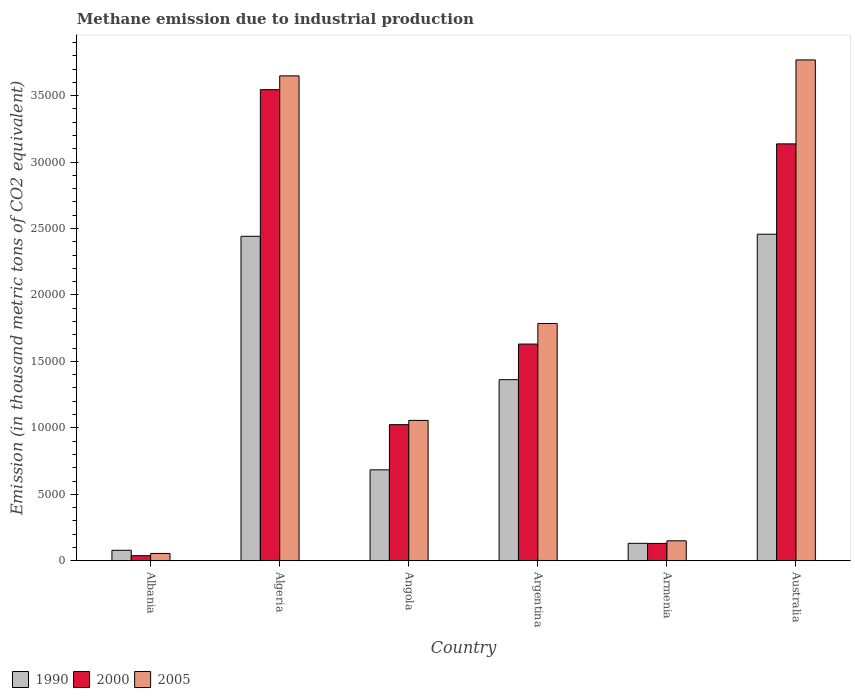How many different coloured bars are there?
Provide a short and direct response. 3. How many groups of bars are there?
Your answer should be compact. 6. What is the label of the 2nd group of bars from the left?
Your answer should be compact. Algeria. In how many cases, is the number of bars for a given country not equal to the number of legend labels?
Provide a short and direct response. 0. What is the amount of methane emitted in 2005 in Algeria?
Offer a very short reply. 3.65e+04. Across all countries, what is the maximum amount of methane emitted in 1990?
Give a very brief answer. 2.46e+04. Across all countries, what is the minimum amount of methane emitted in 2005?
Your answer should be very brief. 550.9. In which country was the amount of methane emitted in 2005 maximum?
Provide a short and direct response. Australia. In which country was the amount of methane emitted in 2000 minimum?
Make the answer very short. Albania. What is the total amount of methane emitted in 2000 in the graph?
Your answer should be compact. 9.51e+04. What is the difference between the amount of methane emitted in 2000 in Algeria and that in Australia?
Offer a very short reply. 4079.4. What is the difference between the amount of methane emitted in 1990 in Armenia and the amount of methane emitted in 2005 in Angola?
Provide a succinct answer. -9249.2. What is the average amount of methane emitted in 2000 per country?
Your answer should be compact. 1.58e+04. What is the difference between the amount of methane emitted of/in 2005 and amount of methane emitted of/in 2000 in Australia?
Your answer should be compact. 6316.4. In how many countries, is the amount of methane emitted in 1990 greater than 14000 thousand metric tons?
Your answer should be compact. 2. What is the ratio of the amount of methane emitted in 2005 in Angola to that in Argentina?
Your response must be concise. 0.59. Is the amount of methane emitted in 2000 in Angola less than that in Australia?
Provide a succinct answer. Yes. Is the difference between the amount of methane emitted in 2005 in Argentina and Australia greater than the difference between the amount of methane emitted in 2000 in Argentina and Australia?
Offer a terse response. No. What is the difference between the highest and the second highest amount of methane emitted in 2005?
Offer a terse response. -1199.5. What is the difference between the highest and the lowest amount of methane emitted in 2005?
Your answer should be compact. 3.71e+04. In how many countries, is the amount of methane emitted in 1990 greater than the average amount of methane emitted in 1990 taken over all countries?
Make the answer very short. 3. Is the sum of the amount of methane emitted in 1990 in Albania and Armenia greater than the maximum amount of methane emitted in 2005 across all countries?
Provide a short and direct response. No. Is it the case that in every country, the sum of the amount of methane emitted in 2005 and amount of methane emitted in 2000 is greater than the amount of methane emitted in 1990?
Ensure brevity in your answer.  Yes. How many bars are there?
Offer a terse response. 18. What is the difference between two consecutive major ticks on the Y-axis?
Your response must be concise. 5000. Are the values on the major ticks of Y-axis written in scientific E-notation?
Give a very brief answer. No. Does the graph contain any zero values?
Make the answer very short. No. Where does the legend appear in the graph?
Provide a short and direct response. Bottom left. What is the title of the graph?
Your answer should be compact. Methane emission due to industrial production. Does "1976" appear as one of the legend labels in the graph?
Your response must be concise. No. What is the label or title of the X-axis?
Ensure brevity in your answer.  Country. What is the label or title of the Y-axis?
Give a very brief answer. Emission (in thousand metric tons of CO2 equivalent). What is the Emission (in thousand metric tons of CO2 equivalent) of 1990 in Albania?
Give a very brief answer. 789.5. What is the Emission (in thousand metric tons of CO2 equivalent) of 2000 in Albania?
Offer a very short reply. 383.4. What is the Emission (in thousand metric tons of CO2 equivalent) of 2005 in Albania?
Give a very brief answer. 550.9. What is the Emission (in thousand metric tons of CO2 equivalent) in 1990 in Algeria?
Ensure brevity in your answer.  2.44e+04. What is the Emission (in thousand metric tons of CO2 equivalent) of 2000 in Algeria?
Your answer should be very brief. 3.54e+04. What is the Emission (in thousand metric tons of CO2 equivalent) in 2005 in Algeria?
Your answer should be compact. 3.65e+04. What is the Emission (in thousand metric tons of CO2 equivalent) of 1990 in Angola?
Your answer should be very brief. 6841.7. What is the Emission (in thousand metric tons of CO2 equivalent) of 2000 in Angola?
Your answer should be compact. 1.02e+04. What is the Emission (in thousand metric tons of CO2 equivalent) in 2005 in Angola?
Provide a short and direct response. 1.06e+04. What is the Emission (in thousand metric tons of CO2 equivalent) of 1990 in Argentina?
Keep it short and to the point. 1.36e+04. What is the Emission (in thousand metric tons of CO2 equivalent) of 2000 in Argentina?
Your answer should be compact. 1.63e+04. What is the Emission (in thousand metric tons of CO2 equivalent) of 2005 in Argentina?
Offer a very short reply. 1.79e+04. What is the Emission (in thousand metric tons of CO2 equivalent) of 1990 in Armenia?
Provide a short and direct response. 1313.2. What is the Emission (in thousand metric tons of CO2 equivalent) in 2000 in Armenia?
Offer a very short reply. 1306.1. What is the Emission (in thousand metric tons of CO2 equivalent) of 2005 in Armenia?
Offer a very short reply. 1502.5. What is the Emission (in thousand metric tons of CO2 equivalent) of 1990 in Australia?
Keep it short and to the point. 2.46e+04. What is the Emission (in thousand metric tons of CO2 equivalent) in 2000 in Australia?
Give a very brief answer. 3.14e+04. What is the Emission (in thousand metric tons of CO2 equivalent) in 2005 in Australia?
Ensure brevity in your answer.  3.77e+04. Across all countries, what is the maximum Emission (in thousand metric tons of CO2 equivalent) of 1990?
Give a very brief answer. 2.46e+04. Across all countries, what is the maximum Emission (in thousand metric tons of CO2 equivalent) of 2000?
Make the answer very short. 3.54e+04. Across all countries, what is the maximum Emission (in thousand metric tons of CO2 equivalent) of 2005?
Make the answer very short. 3.77e+04. Across all countries, what is the minimum Emission (in thousand metric tons of CO2 equivalent) of 1990?
Your answer should be very brief. 789.5. Across all countries, what is the minimum Emission (in thousand metric tons of CO2 equivalent) in 2000?
Your response must be concise. 383.4. Across all countries, what is the minimum Emission (in thousand metric tons of CO2 equivalent) of 2005?
Make the answer very short. 550.9. What is the total Emission (in thousand metric tons of CO2 equivalent) of 1990 in the graph?
Your answer should be compact. 7.16e+04. What is the total Emission (in thousand metric tons of CO2 equivalent) of 2000 in the graph?
Provide a succinct answer. 9.51e+04. What is the total Emission (in thousand metric tons of CO2 equivalent) of 2005 in the graph?
Offer a very short reply. 1.05e+05. What is the difference between the Emission (in thousand metric tons of CO2 equivalent) of 1990 in Albania and that in Algeria?
Your answer should be compact. -2.36e+04. What is the difference between the Emission (in thousand metric tons of CO2 equivalent) of 2000 in Albania and that in Algeria?
Offer a terse response. -3.51e+04. What is the difference between the Emission (in thousand metric tons of CO2 equivalent) of 2005 in Albania and that in Algeria?
Your answer should be very brief. -3.59e+04. What is the difference between the Emission (in thousand metric tons of CO2 equivalent) in 1990 in Albania and that in Angola?
Offer a terse response. -6052.2. What is the difference between the Emission (in thousand metric tons of CO2 equivalent) in 2000 in Albania and that in Angola?
Offer a very short reply. -9857.4. What is the difference between the Emission (in thousand metric tons of CO2 equivalent) of 2005 in Albania and that in Angola?
Offer a very short reply. -1.00e+04. What is the difference between the Emission (in thousand metric tons of CO2 equivalent) of 1990 in Albania and that in Argentina?
Give a very brief answer. -1.28e+04. What is the difference between the Emission (in thousand metric tons of CO2 equivalent) of 2000 in Albania and that in Argentina?
Offer a terse response. -1.59e+04. What is the difference between the Emission (in thousand metric tons of CO2 equivalent) of 2005 in Albania and that in Argentina?
Your answer should be very brief. -1.73e+04. What is the difference between the Emission (in thousand metric tons of CO2 equivalent) in 1990 in Albania and that in Armenia?
Offer a very short reply. -523.7. What is the difference between the Emission (in thousand metric tons of CO2 equivalent) in 2000 in Albania and that in Armenia?
Provide a succinct answer. -922.7. What is the difference between the Emission (in thousand metric tons of CO2 equivalent) in 2005 in Albania and that in Armenia?
Your answer should be very brief. -951.6. What is the difference between the Emission (in thousand metric tons of CO2 equivalent) in 1990 in Albania and that in Australia?
Offer a terse response. -2.38e+04. What is the difference between the Emission (in thousand metric tons of CO2 equivalent) of 2000 in Albania and that in Australia?
Keep it short and to the point. -3.10e+04. What is the difference between the Emission (in thousand metric tons of CO2 equivalent) of 2005 in Albania and that in Australia?
Your answer should be compact. -3.71e+04. What is the difference between the Emission (in thousand metric tons of CO2 equivalent) in 1990 in Algeria and that in Angola?
Your answer should be very brief. 1.76e+04. What is the difference between the Emission (in thousand metric tons of CO2 equivalent) in 2000 in Algeria and that in Angola?
Give a very brief answer. 2.52e+04. What is the difference between the Emission (in thousand metric tons of CO2 equivalent) of 2005 in Algeria and that in Angola?
Ensure brevity in your answer.  2.59e+04. What is the difference between the Emission (in thousand metric tons of CO2 equivalent) in 1990 in Algeria and that in Argentina?
Offer a very short reply. 1.08e+04. What is the difference between the Emission (in thousand metric tons of CO2 equivalent) in 2000 in Algeria and that in Argentina?
Provide a short and direct response. 1.91e+04. What is the difference between the Emission (in thousand metric tons of CO2 equivalent) in 2005 in Algeria and that in Argentina?
Provide a short and direct response. 1.86e+04. What is the difference between the Emission (in thousand metric tons of CO2 equivalent) of 1990 in Algeria and that in Armenia?
Provide a short and direct response. 2.31e+04. What is the difference between the Emission (in thousand metric tons of CO2 equivalent) in 2000 in Algeria and that in Armenia?
Offer a very short reply. 3.41e+04. What is the difference between the Emission (in thousand metric tons of CO2 equivalent) of 2005 in Algeria and that in Armenia?
Your answer should be compact. 3.50e+04. What is the difference between the Emission (in thousand metric tons of CO2 equivalent) of 1990 in Algeria and that in Australia?
Provide a succinct answer. -155.4. What is the difference between the Emission (in thousand metric tons of CO2 equivalent) in 2000 in Algeria and that in Australia?
Ensure brevity in your answer.  4079.4. What is the difference between the Emission (in thousand metric tons of CO2 equivalent) in 2005 in Algeria and that in Australia?
Your response must be concise. -1199.5. What is the difference between the Emission (in thousand metric tons of CO2 equivalent) of 1990 in Angola and that in Argentina?
Your response must be concise. -6785.2. What is the difference between the Emission (in thousand metric tons of CO2 equivalent) in 2000 in Angola and that in Argentina?
Provide a succinct answer. -6063.9. What is the difference between the Emission (in thousand metric tons of CO2 equivalent) of 2005 in Angola and that in Argentina?
Your response must be concise. -7290.6. What is the difference between the Emission (in thousand metric tons of CO2 equivalent) in 1990 in Angola and that in Armenia?
Make the answer very short. 5528.5. What is the difference between the Emission (in thousand metric tons of CO2 equivalent) in 2000 in Angola and that in Armenia?
Provide a short and direct response. 8934.7. What is the difference between the Emission (in thousand metric tons of CO2 equivalent) in 2005 in Angola and that in Armenia?
Provide a succinct answer. 9059.9. What is the difference between the Emission (in thousand metric tons of CO2 equivalent) of 1990 in Angola and that in Australia?
Your response must be concise. -1.77e+04. What is the difference between the Emission (in thousand metric tons of CO2 equivalent) in 2000 in Angola and that in Australia?
Offer a terse response. -2.11e+04. What is the difference between the Emission (in thousand metric tons of CO2 equivalent) in 2005 in Angola and that in Australia?
Make the answer very short. -2.71e+04. What is the difference between the Emission (in thousand metric tons of CO2 equivalent) of 1990 in Argentina and that in Armenia?
Your answer should be very brief. 1.23e+04. What is the difference between the Emission (in thousand metric tons of CO2 equivalent) of 2000 in Argentina and that in Armenia?
Provide a short and direct response. 1.50e+04. What is the difference between the Emission (in thousand metric tons of CO2 equivalent) in 2005 in Argentina and that in Armenia?
Offer a terse response. 1.64e+04. What is the difference between the Emission (in thousand metric tons of CO2 equivalent) in 1990 in Argentina and that in Australia?
Ensure brevity in your answer.  -1.09e+04. What is the difference between the Emission (in thousand metric tons of CO2 equivalent) of 2000 in Argentina and that in Australia?
Your response must be concise. -1.51e+04. What is the difference between the Emission (in thousand metric tons of CO2 equivalent) of 2005 in Argentina and that in Australia?
Ensure brevity in your answer.  -1.98e+04. What is the difference between the Emission (in thousand metric tons of CO2 equivalent) in 1990 in Armenia and that in Australia?
Ensure brevity in your answer.  -2.33e+04. What is the difference between the Emission (in thousand metric tons of CO2 equivalent) in 2000 in Armenia and that in Australia?
Offer a very short reply. -3.01e+04. What is the difference between the Emission (in thousand metric tons of CO2 equivalent) in 2005 in Armenia and that in Australia?
Give a very brief answer. -3.62e+04. What is the difference between the Emission (in thousand metric tons of CO2 equivalent) of 1990 in Albania and the Emission (in thousand metric tons of CO2 equivalent) of 2000 in Algeria?
Provide a succinct answer. -3.47e+04. What is the difference between the Emission (in thousand metric tons of CO2 equivalent) in 1990 in Albania and the Emission (in thousand metric tons of CO2 equivalent) in 2005 in Algeria?
Keep it short and to the point. -3.57e+04. What is the difference between the Emission (in thousand metric tons of CO2 equivalent) of 2000 in Albania and the Emission (in thousand metric tons of CO2 equivalent) of 2005 in Algeria?
Give a very brief answer. -3.61e+04. What is the difference between the Emission (in thousand metric tons of CO2 equivalent) of 1990 in Albania and the Emission (in thousand metric tons of CO2 equivalent) of 2000 in Angola?
Provide a short and direct response. -9451.3. What is the difference between the Emission (in thousand metric tons of CO2 equivalent) in 1990 in Albania and the Emission (in thousand metric tons of CO2 equivalent) in 2005 in Angola?
Make the answer very short. -9772.9. What is the difference between the Emission (in thousand metric tons of CO2 equivalent) in 2000 in Albania and the Emission (in thousand metric tons of CO2 equivalent) in 2005 in Angola?
Provide a succinct answer. -1.02e+04. What is the difference between the Emission (in thousand metric tons of CO2 equivalent) in 1990 in Albania and the Emission (in thousand metric tons of CO2 equivalent) in 2000 in Argentina?
Your answer should be very brief. -1.55e+04. What is the difference between the Emission (in thousand metric tons of CO2 equivalent) in 1990 in Albania and the Emission (in thousand metric tons of CO2 equivalent) in 2005 in Argentina?
Your answer should be very brief. -1.71e+04. What is the difference between the Emission (in thousand metric tons of CO2 equivalent) in 2000 in Albania and the Emission (in thousand metric tons of CO2 equivalent) in 2005 in Argentina?
Offer a terse response. -1.75e+04. What is the difference between the Emission (in thousand metric tons of CO2 equivalent) of 1990 in Albania and the Emission (in thousand metric tons of CO2 equivalent) of 2000 in Armenia?
Offer a very short reply. -516.6. What is the difference between the Emission (in thousand metric tons of CO2 equivalent) in 1990 in Albania and the Emission (in thousand metric tons of CO2 equivalent) in 2005 in Armenia?
Your response must be concise. -713. What is the difference between the Emission (in thousand metric tons of CO2 equivalent) in 2000 in Albania and the Emission (in thousand metric tons of CO2 equivalent) in 2005 in Armenia?
Your answer should be compact. -1119.1. What is the difference between the Emission (in thousand metric tons of CO2 equivalent) in 1990 in Albania and the Emission (in thousand metric tons of CO2 equivalent) in 2000 in Australia?
Give a very brief answer. -3.06e+04. What is the difference between the Emission (in thousand metric tons of CO2 equivalent) in 1990 in Albania and the Emission (in thousand metric tons of CO2 equivalent) in 2005 in Australia?
Keep it short and to the point. -3.69e+04. What is the difference between the Emission (in thousand metric tons of CO2 equivalent) of 2000 in Albania and the Emission (in thousand metric tons of CO2 equivalent) of 2005 in Australia?
Keep it short and to the point. -3.73e+04. What is the difference between the Emission (in thousand metric tons of CO2 equivalent) in 1990 in Algeria and the Emission (in thousand metric tons of CO2 equivalent) in 2000 in Angola?
Your answer should be compact. 1.42e+04. What is the difference between the Emission (in thousand metric tons of CO2 equivalent) in 1990 in Algeria and the Emission (in thousand metric tons of CO2 equivalent) in 2005 in Angola?
Keep it short and to the point. 1.39e+04. What is the difference between the Emission (in thousand metric tons of CO2 equivalent) of 2000 in Algeria and the Emission (in thousand metric tons of CO2 equivalent) of 2005 in Angola?
Give a very brief answer. 2.49e+04. What is the difference between the Emission (in thousand metric tons of CO2 equivalent) of 1990 in Algeria and the Emission (in thousand metric tons of CO2 equivalent) of 2000 in Argentina?
Offer a very short reply. 8110.1. What is the difference between the Emission (in thousand metric tons of CO2 equivalent) in 1990 in Algeria and the Emission (in thousand metric tons of CO2 equivalent) in 2005 in Argentina?
Your response must be concise. 6561.8. What is the difference between the Emission (in thousand metric tons of CO2 equivalent) in 2000 in Algeria and the Emission (in thousand metric tons of CO2 equivalent) in 2005 in Argentina?
Give a very brief answer. 1.76e+04. What is the difference between the Emission (in thousand metric tons of CO2 equivalent) of 1990 in Algeria and the Emission (in thousand metric tons of CO2 equivalent) of 2000 in Armenia?
Provide a succinct answer. 2.31e+04. What is the difference between the Emission (in thousand metric tons of CO2 equivalent) in 1990 in Algeria and the Emission (in thousand metric tons of CO2 equivalent) in 2005 in Armenia?
Offer a terse response. 2.29e+04. What is the difference between the Emission (in thousand metric tons of CO2 equivalent) of 2000 in Algeria and the Emission (in thousand metric tons of CO2 equivalent) of 2005 in Armenia?
Keep it short and to the point. 3.39e+04. What is the difference between the Emission (in thousand metric tons of CO2 equivalent) of 1990 in Algeria and the Emission (in thousand metric tons of CO2 equivalent) of 2000 in Australia?
Keep it short and to the point. -6953.2. What is the difference between the Emission (in thousand metric tons of CO2 equivalent) of 1990 in Algeria and the Emission (in thousand metric tons of CO2 equivalent) of 2005 in Australia?
Your response must be concise. -1.33e+04. What is the difference between the Emission (in thousand metric tons of CO2 equivalent) of 2000 in Algeria and the Emission (in thousand metric tons of CO2 equivalent) of 2005 in Australia?
Ensure brevity in your answer.  -2237. What is the difference between the Emission (in thousand metric tons of CO2 equivalent) of 1990 in Angola and the Emission (in thousand metric tons of CO2 equivalent) of 2000 in Argentina?
Give a very brief answer. -9463. What is the difference between the Emission (in thousand metric tons of CO2 equivalent) of 1990 in Angola and the Emission (in thousand metric tons of CO2 equivalent) of 2005 in Argentina?
Your response must be concise. -1.10e+04. What is the difference between the Emission (in thousand metric tons of CO2 equivalent) of 2000 in Angola and the Emission (in thousand metric tons of CO2 equivalent) of 2005 in Argentina?
Ensure brevity in your answer.  -7612.2. What is the difference between the Emission (in thousand metric tons of CO2 equivalent) of 1990 in Angola and the Emission (in thousand metric tons of CO2 equivalent) of 2000 in Armenia?
Ensure brevity in your answer.  5535.6. What is the difference between the Emission (in thousand metric tons of CO2 equivalent) in 1990 in Angola and the Emission (in thousand metric tons of CO2 equivalent) in 2005 in Armenia?
Your answer should be very brief. 5339.2. What is the difference between the Emission (in thousand metric tons of CO2 equivalent) of 2000 in Angola and the Emission (in thousand metric tons of CO2 equivalent) of 2005 in Armenia?
Your answer should be compact. 8738.3. What is the difference between the Emission (in thousand metric tons of CO2 equivalent) in 1990 in Angola and the Emission (in thousand metric tons of CO2 equivalent) in 2000 in Australia?
Make the answer very short. -2.45e+04. What is the difference between the Emission (in thousand metric tons of CO2 equivalent) of 1990 in Angola and the Emission (in thousand metric tons of CO2 equivalent) of 2005 in Australia?
Ensure brevity in your answer.  -3.08e+04. What is the difference between the Emission (in thousand metric tons of CO2 equivalent) in 2000 in Angola and the Emission (in thousand metric tons of CO2 equivalent) in 2005 in Australia?
Provide a succinct answer. -2.74e+04. What is the difference between the Emission (in thousand metric tons of CO2 equivalent) of 1990 in Argentina and the Emission (in thousand metric tons of CO2 equivalent) of 2000 in Armenia?
Your answer should be very brief. 1.23e+04. What is the difference between the Emission (in thousand metric tons of CO2 equivalent) in 1990 in Argentina and the Emission (in thousand metric tons of CO2 equivalent) in 2005 in Armenia?
Make the answer very short. 1.21e+04. What is the difference between the Emission (in thousand metric tons of CO2 equivalent) in 2000 in Argentina and the Emission (in thousand metric tons of CO2 equivalent) in 2005 in Armenia?
Your answer should be compact. 1.48e+04. What is the difference between the Emission (in thousand metric tons of CO2 equivalent) in 1990 in Argentina and the Emission (in thousand metric tons of CO2 equivalent) in 2000 in Australia?
Provide a short and direct response. -1.77e+04. What is the difference between the Emission (in thousand metric tons of CO2 equivalent) in 1990 in Argentina and the Emission (in thousand metric tons of CO2 equivalent) in 2005 in Australia?
Your answer should be very brief. -2.41e+04. What is the difference between the Emission (in thousand metric tons of CO2 equivalent) of 2000 in Argentina and the Emission (in thousand metric tons of CO2 equivalent) of 2005 in Australia?
Your answer should be compact. -2.14e+04. What is the difference between the Emission (in thousand metric tons of CO2 equivalent) in 1990 in Armenia and the Emission (in thousand metric tons of CO2 equivalent) in 2000 in Australia?
Your response must be concise. -3.01e+04. What is the difference between the Emission (in thousand metric tons of CO2 equivalent) of 1990 in Armenia and the Emission (in thousand metric tons of CO2 equivalent) of 2005 in Australia?
Provide a succinct answer. -3.64e+04. What is the difference between the Emission (in thousand metric tons of CO2 equivalent) in 2000 in Armenia and the Emission (in thousand metric tons of CO2 equivalent) in 2005 in Australia?
Give a very brief answer. -3.64e+04. What is the average Emission (in thousand metric tons of CO2 equivalent) in 1990 per country?
Your response must be concise. 1.19e+04. What is the average Emission (in thousand metric tons of CO2 equivalent) in 2000 per country?
Provide a succinct answer. 1.58e+04. What is the average Emission (in thousand metric tons of CO2 equivalent) of 2005 per country?
Your answer should be compact. 1.74e+04. What is the difference between the Emission (in thousand metric tons of CO2 equivalent) of 1990 and Emission (in thousand metric tons of CO2 equivalent) of 2000 in Albania?
Keep it short and to the point. 406.1. What is the difference between the Emission (in thousand metric tons of CO2 equivalent) in 1990 and Emission (in thousand metric tons of CO2 equivalent) in 2005 in Albania?
Your answer should be very brief. 238.6. What is the difference between the Emission (in thousand metric tons of CO2 equivalent) of 2000 and Emission (in thousand metric tons of CO2 equivalent) of 2005 in Albania?
Offer a very short reply. -167.5. What is the difference between the Emission (in thousand metric tons of CO2 equivalent) in 1990 and Emission (in thousand metric tons of CO2 equivalent) in 2000 in Algeria?
Your answer should be very brief. -1.10e+04. What is the difference between the Emission (in thousand metric tons of CO2 equivalent) of 1990 and Emission (in thousand metric tons of CO2 equivalent) of 2005 in Algeria?
Your answer should be compact. -1.21e+04. What is the difference between the Emission (in thousand metric tons of CO2 equivalent) of 2000 and Emission (in thousand metric tons of CO2 equivalent) of 2005 in Algeria?
Keep it short and to the point. -1037.5. What is the difference between the Emission (in thousand metric tons of CO2 equivalent) of 1990 and Emission (in thousand metric tons of CO2 equivalent) of 2000 in Angola?
Offer a very short reply. -3399.1. What is the difference between the Emission (in thousand metric tons of CO2 equivalent) in 1990 and Emission (in thousand metric tons of CO2 equivalent) in 2005 in Angola?
Make the answer very short. -3720.7. What is the difference between the Emission (in thousand metric tons of CO2 equivalent) in 2000 and Emission (in thousand metric tons of CO2 equivalent) in 2005 in Angola?
Your answer should be compact. -321.6. What is the difference between the Emission (in thousand metric tons of CO2 equivalent) of 1990 and Emission (in thousand metric tons of CO2 equivalent) of 2000 in Argentina?
Give a very brief answer. -2677.8. What is the difference between the Emission (in thousand metric tons of CO2 equivalent) in 1990 and Emission (in thousand metric tons of CO2 equivalent) in 2005 in Argentina?
Keep it short and to the point. -4226.1. What is the difference between the Emission (in thousand metric tons of CO2 equivalent) in 2000 and Emission (in thousand metric tons of CO2 equivalent) in 2005 in Argentina?
Provide a short and direct response. -1548.3. What is the difference between the Emission (in thousand metric tons of CO2 equivalent) of 1990 and Emission (in thousand metric tons of CO2 equivalent) of 2000 in Armenia?
Offer a very short reply. 7.1. What is the difference between the Emission (in thousand metric tons of CO2 equivalent) in 1990 and Emission (in thousand metric tons of CO2 equivalent) in 2005 in Armenia?
Your answer should be compact. -189.3. What is the difference between the Emission (in thousand metric tons of CO2 equivalent) in 2000 and Emission (in thousand metric tons of CO2 equivalent) in 2005 in Armenia?
Ensure brevity in your answer.  -196.4. What is the difference between the Emission (in thousand metric tons of CO2 equivalent) in 1990 and Emission (in thousand metric tons of CO2 equivalent) in 2000 in Australia?
Offer a terse response. -6797.8. What is the difference between the Emission (in thousand metric tons of CO2 equivalent) in 1990 and Emission (in thousand metric tons of CO2 equivalent) in 2005 in Australia?
Your response must be concise. -1.31e+04. What is the difference between the Emission (in thousand metric tons of CO2 equivalent) of 2000 and Emission (in thousand metric tons of CO2 equivalent) of 2005 in Australia?
Provide a short and direct response. -6316.4. What is the ratio of the Emission (in thousand metric tons of CO2 equivalent) in 1990 in Albania to that in Algeria?
Keep it short and to the point. 0.03. What is the ratio of the Emission (in thousand metric tons of CO2 equivalent) of 2000 in Albania to that in Algeria?
Your answer should be compact. 0.01. What is the ratio of the Emission (in thousand metric tons of CO2 equivalent) of 2005 in Albania to that in Algeria?
Provide a short and direct response. 0.02. What is the ratio of the Emission (in thousand metric tons of CO2 equivalent) of 1990 in Albania to that in Angola?
Your answer should be compact. 0.12. What is the ratio of the Emission (in thousand metric tons of CO2 equivalent) in 2000 in Albania to that in Angola?
Your answer should be compact. 0.04. What is the ratio of the Emission (in thousand metric tons of CO2 equivalent) of 2005 in Albania to that in Angola?
Your answer should be compact. 0.05. What is the ratio of the Emission (in thousand metric tons of CO2 equivalent) of 1990 in Albania to that in Argentina?
Provide a succinct answer. 0.06. What is the ratio of the Emission (in thousand metric tons of CO2 equivalent) of 2000 in Albania to that in Argentina?
Your answer should be compact. 0.02. What is the ratio of the Emission (in thousand metric tons of CO2 equivalent) in 2005 in Albania to that in Argentina?
Offer a terse response. 0.03. What is the ratio of the Emission (in thousand metric tons of CO2 equivalent) of 1990 in Albania to that in Armenia?
Provide a short and direct response. 0.6. What is the ratio of the Emission (in thousand metric tons of CO2 equivalent) in 2000 in Albania to that in Armenia?
Your response must be concise. 0.29. What is the ratio of the Emission (in thousand metric tons of CO2 equivalent) of 2005 in Albania to that in Armenia?
Ensure brevity in your answer.  0.37. What is the ratio of the Emission (in thousand metric tons of CO2 equivalent) in 1990 in Albania to that in Australia?
Give a very brief answer. 0.03. What is the ratio of the Emission (in thousand metric tons of CO2 equivalent) in 2000 in Albania to that in Australia?
Provide a succinct answer. 0.01. What is the ratio of the Emission (in thousand metric tons of CO2 equivalent) in 2005 in Albania to that in Australia?
Offer a very short reply. 0.01. What is the ratio of the Emission (in thousand metric tons of CO2 equivalent) of 1990 in Algeria to that in Angola?
Your response must be concise. 3.57. What is the ratio of the Emission (in thousand metric tons of CO2 equivalent) in 2000 in Algeria to that in Angola?
Your answer should be very brief. 3.46. What is the ratio of the Emission (in thousand metric tons of CO2 equivalent) in 2005 in Algeria to that in Angola?
Offer a terse response. 3.45. What is the ratio of the Emission (in thousand metric tons of CO2 equivalent) of 1990 in Algeria to that in Argentina?
Your answer should be compact. 1.79. What is the ratio of the Emission (in thousand metric tons of CO2 equivalent) in 2000 in Algeria to that in Argentina?
Ensure brevity in your answer.  2.17. What is the ratio of the Emission (in thousand metric tons of CO2 equivalent) of 2005 in Algeria to that in Argentina?
Provide a short and direct response. 2.04. What is the ratio of the Emission (in thousand metric tons of CO2 equivalent) of 1990 in Algeria to that in Armenia?
Your answer should be very brief. 18.59. What is the ratio of the Emission (in thousand metric tons of CO2 equivalent) of 2000 in Algeria to that in Armenia?
Give a very brief answer. 27.14. What is the ratio of the Emission (in thousand metric tons of CO2 equivalent) in 2005 in Algeria to that in Armenia?
Your answer should be compact. 24.28. What is the ratio of the Emission (in thousand metric tons of CO2 equivalent) of 1990 in Algeria to that in Australia?
Your response must be concise. 0.99. What is the ratio of the Emission (in thousand metric tons of CO2 equivalent) of 2000 in Algeria to that in Australia?
Provide a succinct answer. 1.13. What is the ratio of the Emission (in thousand metric tons of CO2 equivalent) in 2005 in Algeria to that in Australia?
Keep it short and to the point. 0.97. What is the ratio of the Emission (in thousand metric tons of CO2 equivalent) of 1990 in Angola to that in Argentina?
Provide a succinct answer. 0.5. What is the ratio of the Emission (in thousand metric tons of CO2 equivalent) of 2000 in Angola to that in Argentina?
Ensure brevity in your answer.  0.63. What is the ratio of the Emission (in thousand metric tons of CO2 equivalent) of 2005 in Angola to that in Argentina?
Offer a terse response. 0.59. What is the ratio of the Emission (in thousand metric tons of CO2 equivalent) of 1990 in Angola to that in Armenia?
Your response must be concise. 5.21. What is the ratio of the Emission (in thousand metric tons of CO2 equivalent) of 2000 in Angola to that in Armenia?
Keep it short and to the point. 7.84. What is the ratio of the Emission (in thousand metric tons of CO2 equivalent) in 2005 in Angola to that in Armenia?
Give a very brief answer. 7.03. What is the ratio of the Emission (in thousand metric tons of CO2 equivalent) of 1990 in Angola to that in Australia?
Ensure brevity in your answer.  0.28. What is the ratio of the Emission (in thousand metric tons of CO2 equivalent) of 2000 in Angola to that in Australia?
Provide a succinct answer. 0.33. What is the ratio of the Emission (in thousand metric tons of CO2 equivalent) in 2005 in Angola to that in Australia?
Your response must be concise. 0.28. What is the ratio of the Emission (in thousand metric tons of CO2 equivalent) in 1990 in Argentina to that in Armenia?
Give a very brief answer. 10.38. What is the ratio of the Emission (in thousand metric tons of CO2 equivalent) in 2000 in Argentina to that in Armenia?
Give a very brief answer. 12.48. What is the ratio of the Emission (in thousand metric tons of CO2 equivalent) in 2005 in Argentina to that in Armenia?
Offer a terse response. 11.88. What is the ratio of the Emission (in thousand metric tons of CO2 equivalent) in 1990 in Argentina to that in Australia?
Your answer should be very brief. 0.55. What is the ratio of the Emission (in thousand metric tons of CO2 equivalent) in 2000 in Argentina to that in Australia?
Offer a terse response. 0.52. What is the ratio of the Emission (in thousand metric tons of CO2 equivalent) of 2005 in Argentina to that in Australia?
Your answer should be compact. 0.47. What is the ratio of the Emission (in thousand metric tons of CO2 equivalent) of 1990 in Armenia to that in Australia?
Keep it short and to the point. 0.05. What is the ratio of the Emission (in thousand metric tons of CO2 equivalent) of 2000 in Armenia to that in Australia?
Provide a short and direct response. 0.04. What is the ratio of the Emission (in thousand metric tons of CO2 equivalent) of 2005 in Armenia to that in Australia?
Make the answer very short. 0.04. What is the difference between the highest and the second highest Emission (in thousand metric tons of CO2 equivalent) of 1990?
Offer a terse response. 155.4. What is the difference between the highest and the second highest Emission (in thousand metric tons of CO2 equivalent) of 2000?
Your answer should be very brief. 4079.4. What is the difference between the highest and the second highest Emission (in thousand metric tons of CO2 equivalent) in 2005?
Provide a short and direct response. 1199.5. What is the difference between the highest and the lowest Emission (in thousand metric tons of CO2 equivalent) in 1990?
Your answer should be compact. 2.38e+04. What is the difference between the highest and the lowest Emission (in thousand metric tons of CO2 equivalent) in 2000?
Provide a short and direct response. 3.51e+04. What is the difference between the highest and the lowest Emission (in thousand metric tons of CO2 equivalent) in 2005?
Make the answer very short. 3.71e+04. 